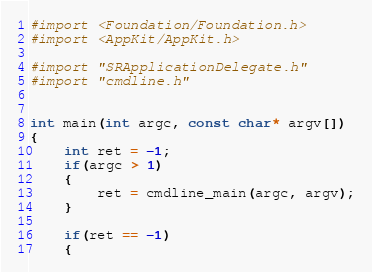Convert code to text. <code><loc_0><loc_0><loc_500><loc_500><_ObjectiveC_>

#import <Foundation/Foundation.h>
#import <AppKit/AppKit.h>

#import "SRApplicationDelegate.h"
#import "cmdline.h"


int main(int argc, const char* argv[])
{
	int ret = -1;
	if(argc > 1)
	{
		ret = cmdline_main(argc, argv);
	}
	
	if(ret == -1)
	{</code> 